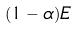<formula> <loc_0><loc_0><loc_500><loc_500>( 1 - \alpha ) E</formula> 